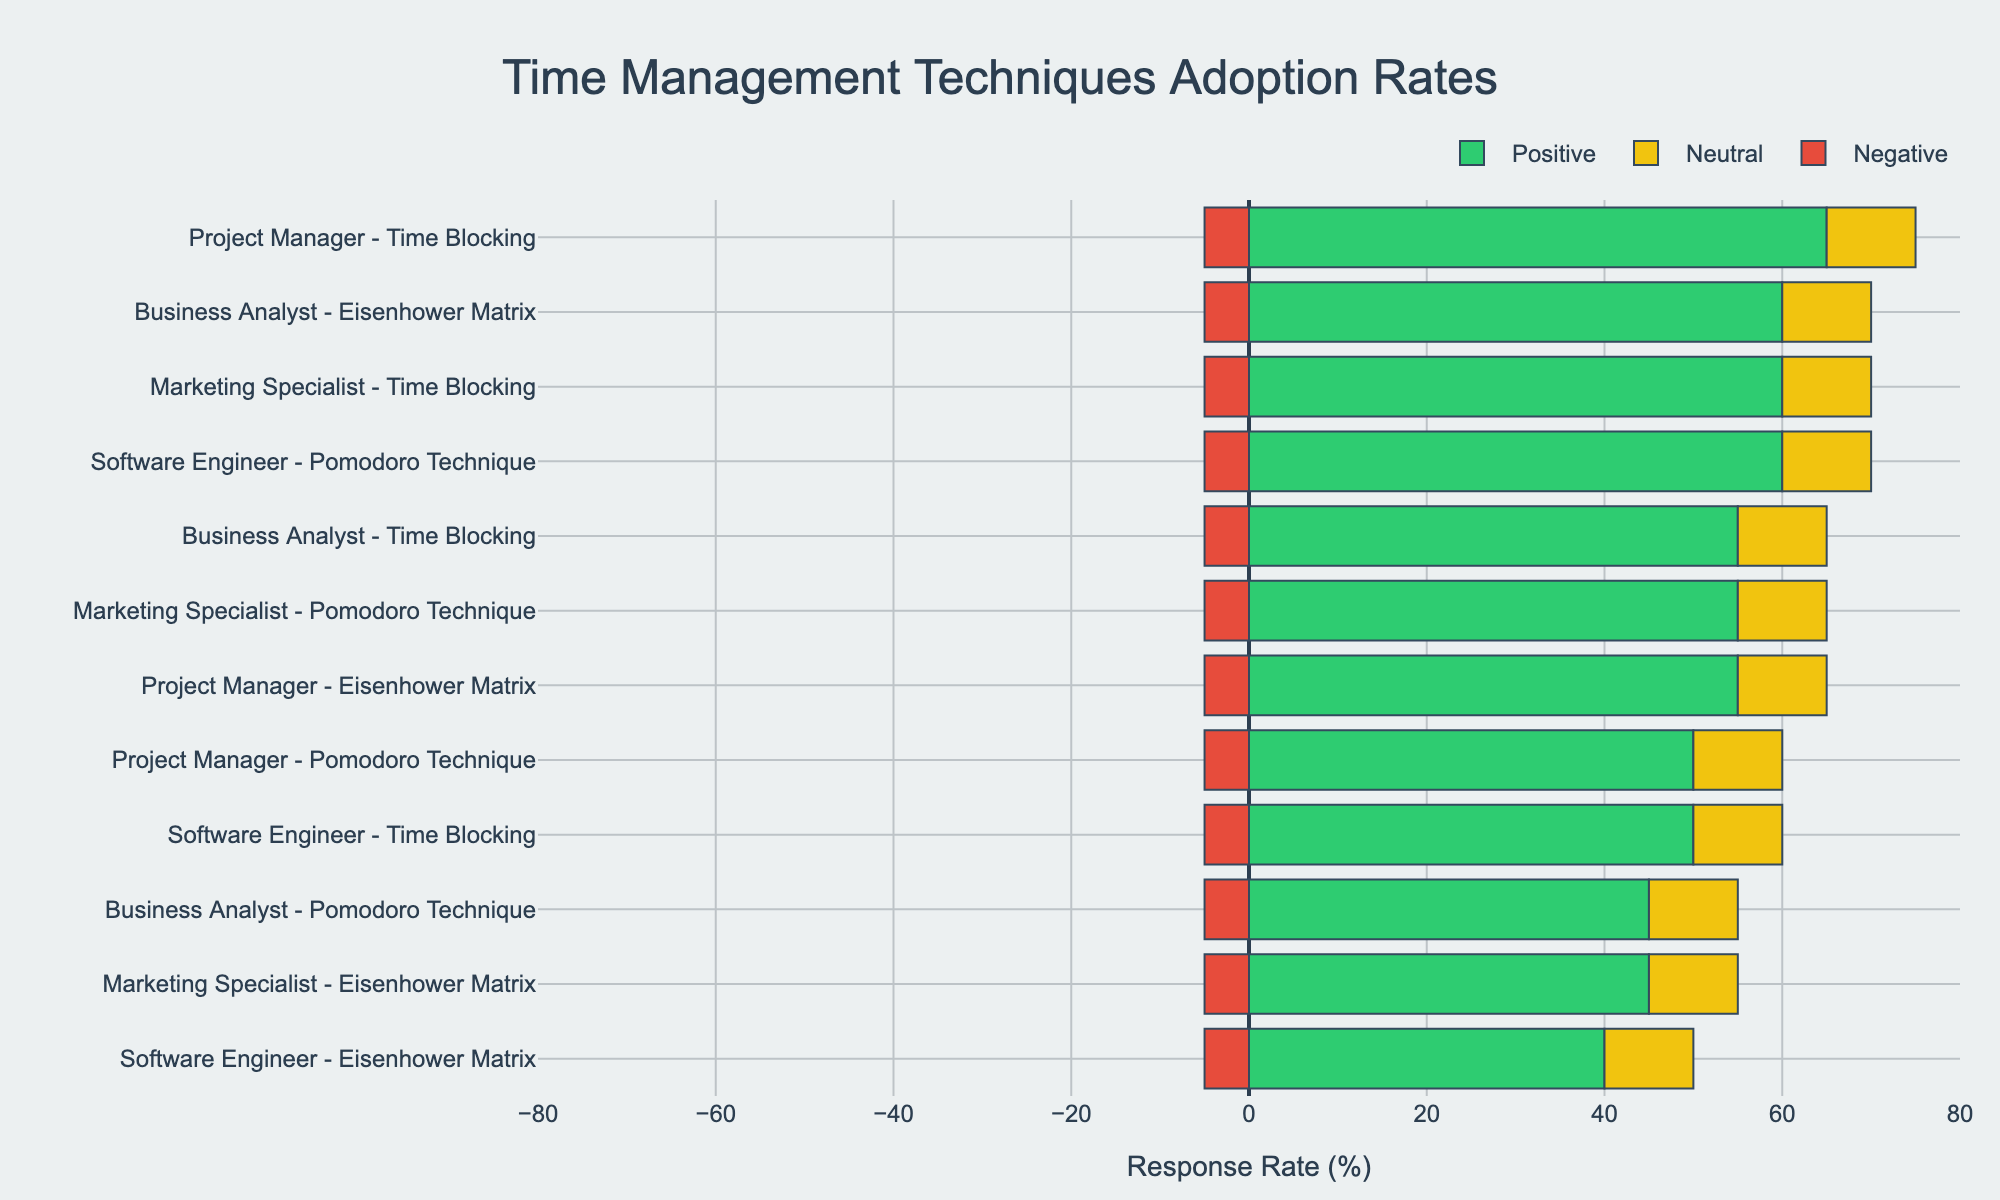Which professional role has the highest positive response for the Pomodoro Technique? The chart shows multiple bars for different roles and techniques. Look for the 'Pomodoro Technique' row in each professional role section and identify the height of the green bar (PositiveResponse). The Business Analyst has the highest positive response with 45%.
Answer: Business Analyst What is the difference in the positive response rate between time blocking for software engineers and project managers? Locate the green bars for time blocking under the Software Engineer and Project Manager roles. The positive response rate is 50% for Software Engineers and 65% for Project Managers. The difference is 65% - 50% = 15%.
Answer: 15% Which technique has the most balanced responses (positive, neutral, and negative) among Marketing Specialists? Balanced responses would mean relatively equal bar lengths. Compare the three techniques (Pomodoro Technique, Time Blocking, and Eisenhower Matrix) under Marketing Specialists. Time Blocking shows a more balanced response ratio with green, yellow, and red bars being relatively similar compared to the others.
Answer: Time Blocking What is the average positive response rate for the Eisenhower Matrix technique across all roles? Gather the positive response rates for the Eisenhower Matrix for all roles: 40% (Software Engineer), 55% (Project Manager), 45% (Marketing Specialist), 60% (Business Analyst). Calculate the average by summing up the percentages and dividing by the number of entries: (40+55+45+60)/4 = 200/4 = 50%.
Answer: 50% For which professional role does the negative response for time blocking exceed the positive response for the Pomodoro Technique? Compare the green bars for the Pomodoro Technique and the red bars for time blocking across all roles. The only scenario where the negative response exceeds the positive response for the Pomodoro Technique happens with Project Managers, where the negative response for time blocking is 10% and the positive response for the Pomodoro Technique is 5%.
Answer: None Which technique has the highest overall adoption rate across all professional roles? Review the overall adoption rate percentage for all techniques and find the highest value. Time Blocking has adoption rates of 65%, 80%, 75%, 70% respectively, which is consistently high across roles.
Answer: Time Blocking If a professional's likelihood to try a technique correlates with its adoption rate, which role is most likely to adopt the Eisenhower Matrix? Identify the adoption rate for the Eisenhower Matrix across all roles. Business Analyst has the highest adoption rate at 75%.
Answer: Business Analyst 